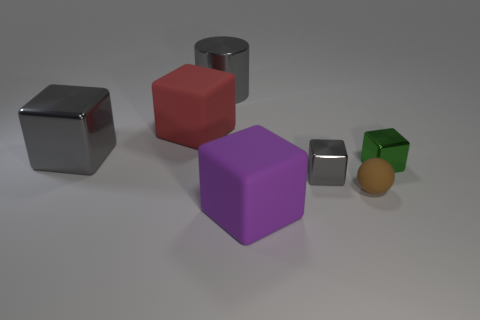Add 2 green shiny objects. How many objects exist? 9 Subtract all red blocks. How many blocks are left? 4 Subtract 1 blocks. How many blocks are left? 4 Subtract all green objects. Subtract all small green blocks. How many objects are left? 5 Add 6 large blocks. How many large blocks are left? 9 Add 6 gray metallic objects. How many gray metallic objects exist? 9 Subtract all red cubes. How many cubes are left? 4 Subtract 0 purple spheres. How many objects are left? 7 Subtract all spheres. How many objects are left? 6 Subtract all yellow cubes. Subtract all brown spheres. How many cubes are left? 5 